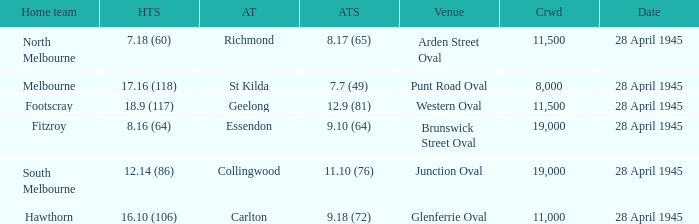Which home team has an Away team of essendon? 8.16 (64). 